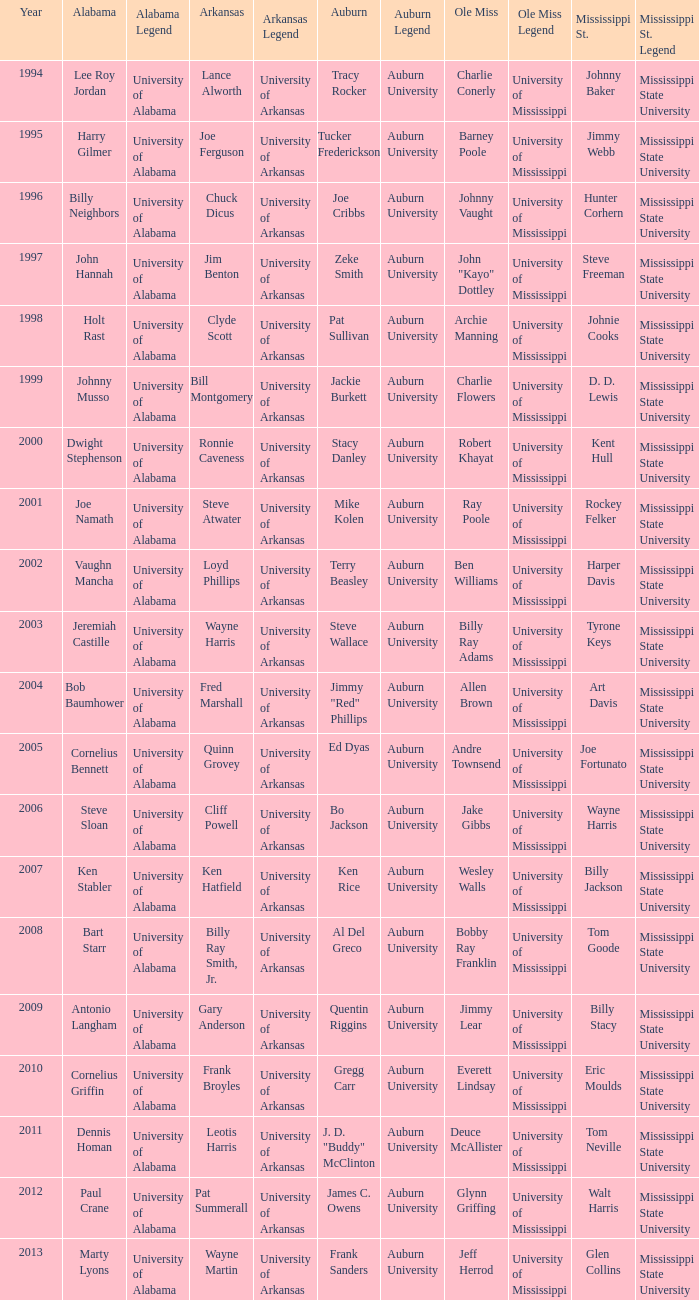Who was the Ole Miss player associated with Chuck Dicus? Johnny Vaught. 